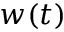Convert formula to latex. <formula><loc_0><loc_0><loc_500><loc_500>w ( t )</formula> 